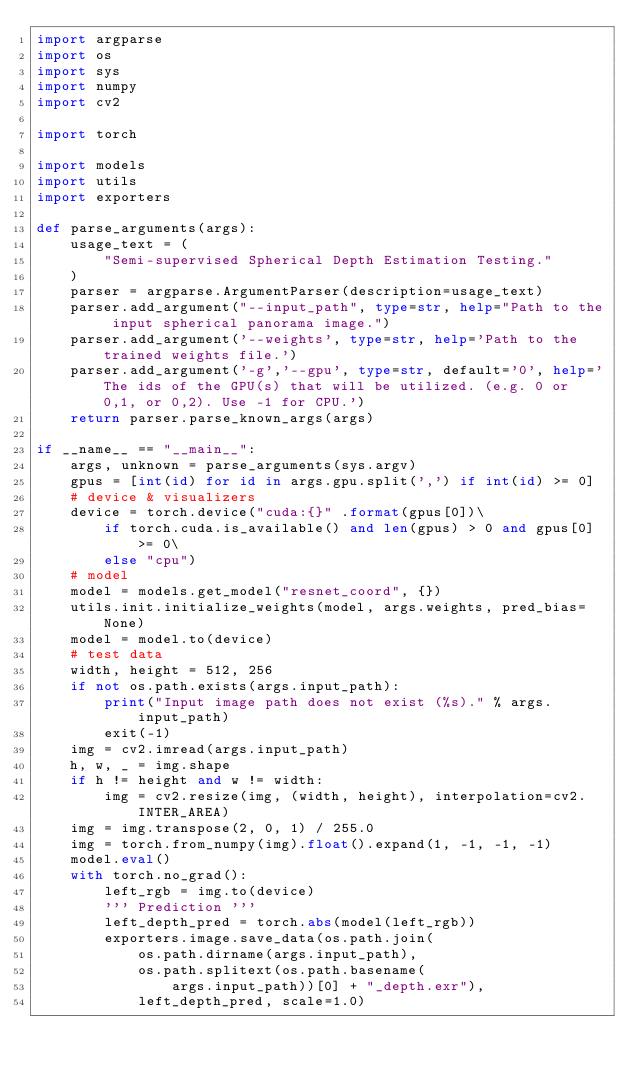<code> <loc_0><loc_0><loc_500><loc_500><_Python_>import argparse
import os
import sys
import numpy
import cv2

import torch

import models
import utils
import exporters

def parse_arguments(args):
    usage_text = (
        "Semi-supervised Spherical Depth Estimation Testing."        
    )
    parser = argparse.ArgumentParser(description=usage_text)    
    parser.add_argument("--input_path", type=str, help="Path to the input spherical panorama image.")
    parser.add_argument('--weights', type=str, help='Path to the trained weights file.')    
    parser.add_argument('-g','--gpu', type=str, default='0', help='The ids of the GPU(s) that will be utilized. (e.g. 0 or 0,1, or 0,2). Use -1 for CPU.')        
    return parser.parse_known_args(args)

if __name__ == "__main__":
    args, unknown = parse_arguments(sys.argv)
    gpus = [int(id) for id in args.gpu.split(',') if int(id) >= 0]
    # device & visualizers
    device = torch.device("cuda:{}" .format(gpus[0])\
        if torch.cuda.is_available() and len(gpus) > 0 and gpus[0] >= 0\
        else "cpu")    
    # model    
    model = models.get_model("resnet_coord", {})
    utils.init.initialize_weights(model, args.weights, pred_bias=None)
    model = model.to(device)
    # test data
    width, height = 512, 256
    if not os.path.exists(args.input_path):
        print("Input image path does not exist (%s)." % args.input_path)
        exit(-1)
    img = cv2.imread(args.input_path)
    h, w, _ = img.shape
    if h != height and w != width:
        img = cv2.resize(img, (width, height), interpolation=cv2.INTER_AREA)
    img = img.transpose(2, 0, 1) / 255.0
    img = torch.from_numpy(img).float().expand(1, -1, -1, -1)
    model.eval()
    with torch.no_grad():                    
        left_rgb = img.to(device)
        ''' Prediction '''
        left_depth_pred = torch.abs(model(left_rgb))
        exporters.image.save_data(os.path.join(
            os.path.dirname(args.input_path),
            os.path.splitext(os.path.basename(
                args.input_path))[0] + "_depth.exr"),
            left_depth_pred, scale=1.0)
</code> 